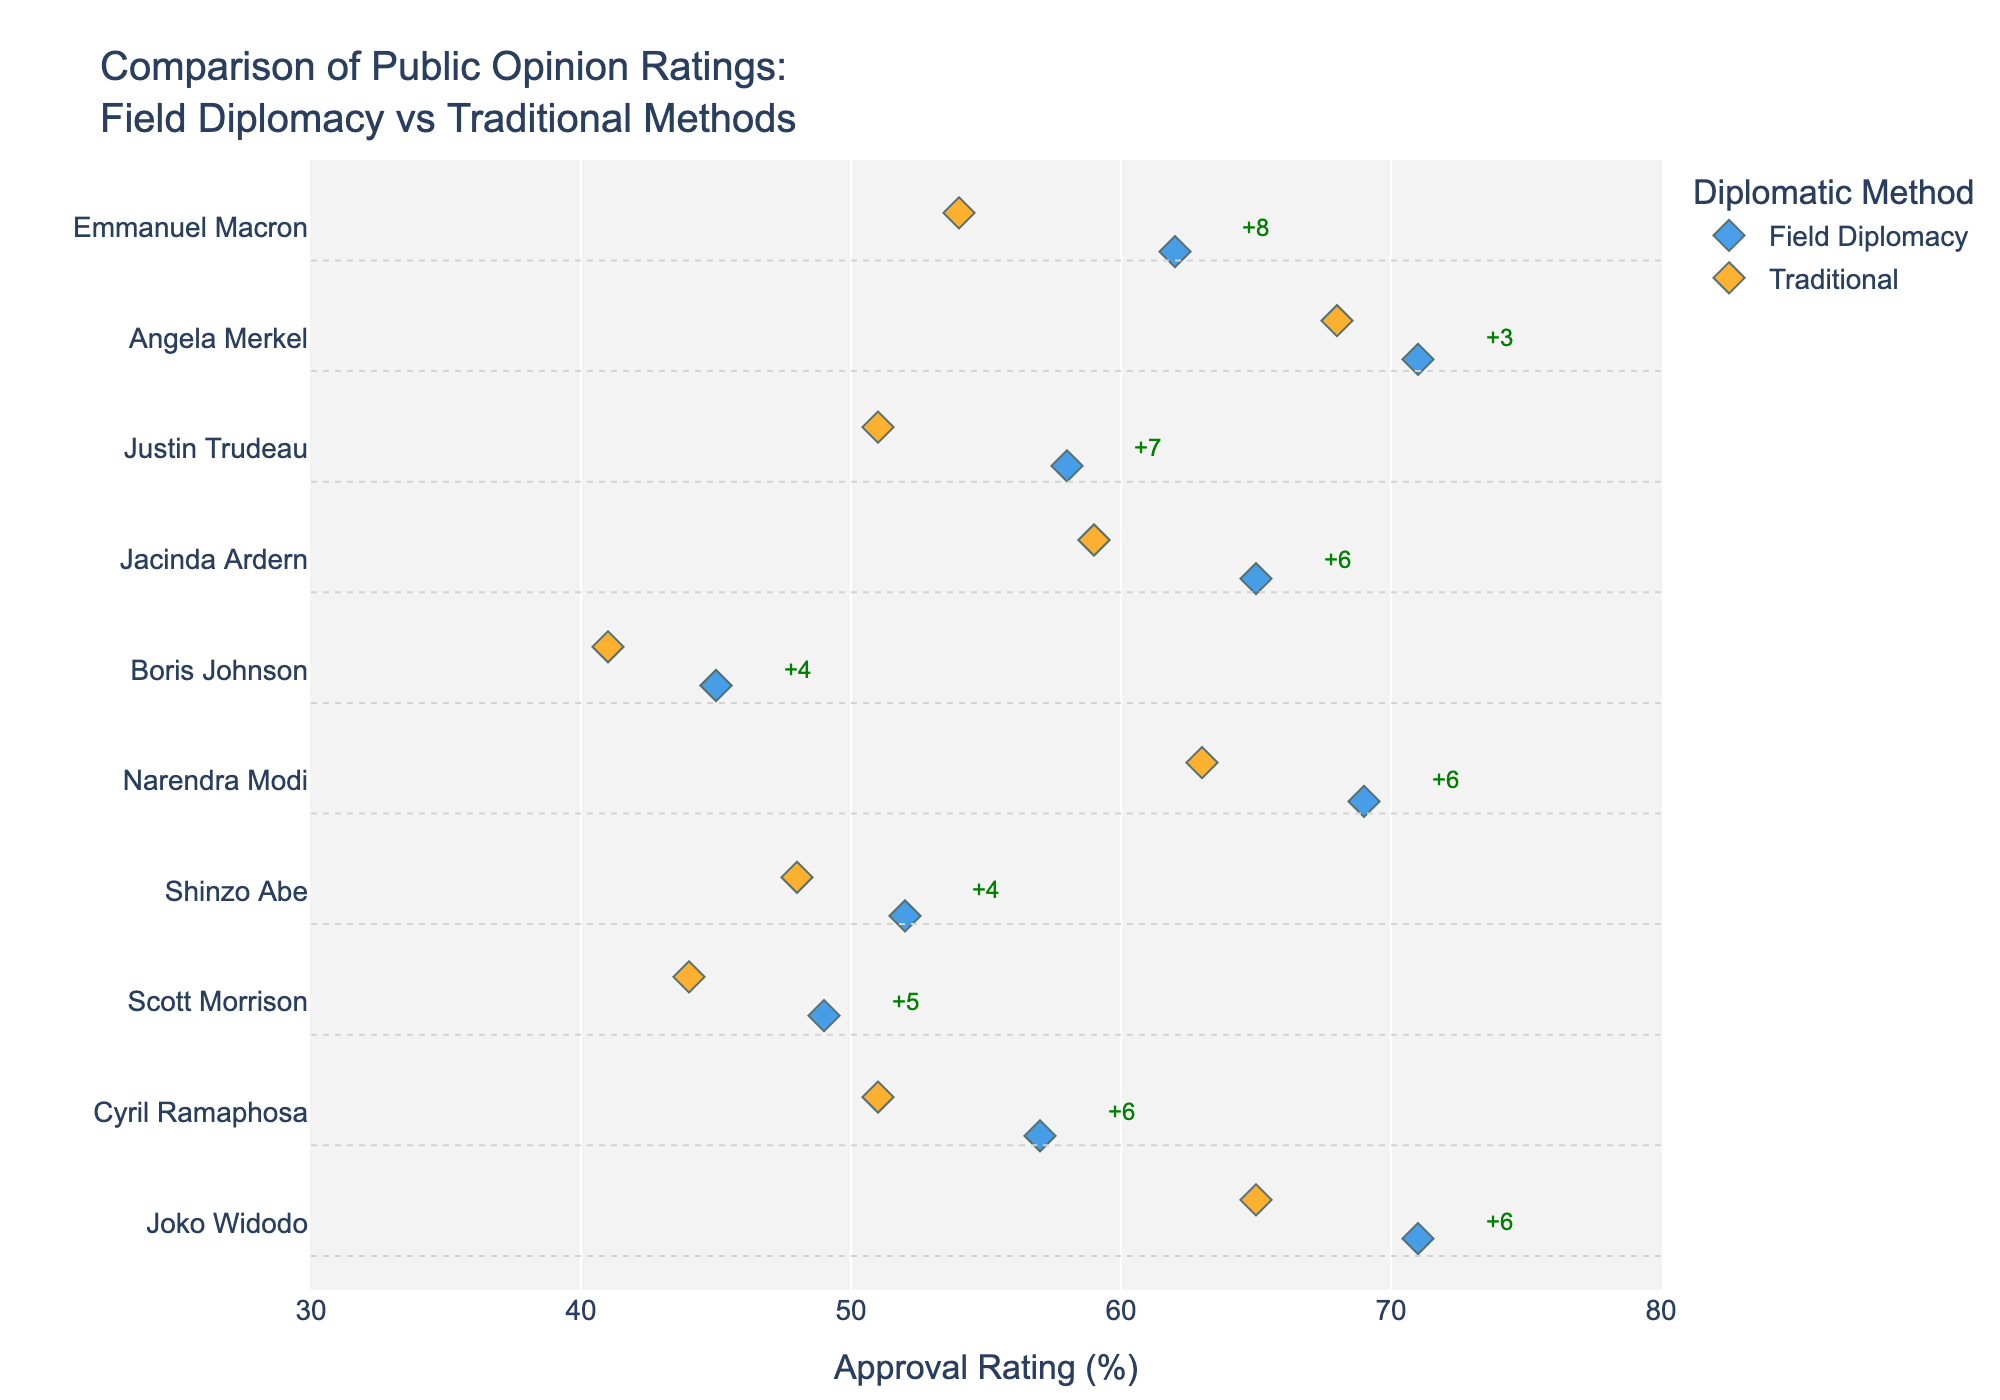What's the title of the plot? The title of the plot is written at the top center of the figure. It reads "Comparison of Public Opinion Ratings: Field Diplomacy vs Traditional Methods".
Answer: "Comparison of Public Opinion Ratings: Field Diplomacy vs Traditional Methods" What is the approval rating of Angela Merkel when she uses Field Diplomacy? By looking at the data points associated with Angela Merkel on the strip plot, the approval rating corresponding to Field Diplomacy is marked as 71.
Answer: 71 Which politician has the highest approval rating for Field Diplomacy? By scanning the y-axis and the x-axis for Field Diplomacy, Joko Widodo shows the highest approval rating at 71.
Answer: Joko Widodo What is the difference in approval rating between Field Diplomacy and Traditional for Justin Trudeau? The approval rating for Justin Trudeau with Field Diplomacy is 58 and for Traditional methods is 51. The difference is calculated as 58 - 51 = 7.
Answer: 7 How much higher is the approval rating for Field Diplomacy compared to Traditional methods for Narendra Modi? Narendra Modi has an approval rating of 69 for Field Diplomacy and 63 for Traditional methods. The difference is 69 - 63 = 6.
Answer: 6 Which politician shows the smallest difference in approval ratings between the two methods? By looking at the annotations in the plot that indicate the difference for each politician, Boris Johnson shows the smallest difference of 4 (45 for Field Diplomacy and 41 for Traditional methods).
Answer: Boris Johnson What is the median approval rating of Field Diplomacy among all politicians? Approval ratings for Field Diplomacy are 62, 71, 58, 65, 45, 69, 52, 49, 57, 71. Sorting these values in order: 45, 49, 52, 57, 58, 62, 65, 69, 71, 71. As there are 10 data points, the median is the average of the 5th and 6th values: (58 + 62) / 2 = 60.
Answer: 60 Among the politicians listed, who has the lowest approval rating for Traditional methods? By reviewing the x-axis positions for Traditional methods, Boris Johnson has the lowest approval rating at 41.
Answer: Boris Johnson Which method, Field Diplomacy or Traditional, generally has higher approval ratings? By comparing the overall trend in the plotted data points, it is evident that Field Diplomacy generally has higher approval ratings compared to Traditional methods.
Answer: Field Diplomacy For which politician does Field Diplomacy outperform Traditional methods by the largest margin? By examining the annotations, Cyril Ramaphosa shows the largest margin where Field Diplomacy outperforms Traditional methods by +6 (57 vs. 51).
Answer: Cyril Ramaphosa 